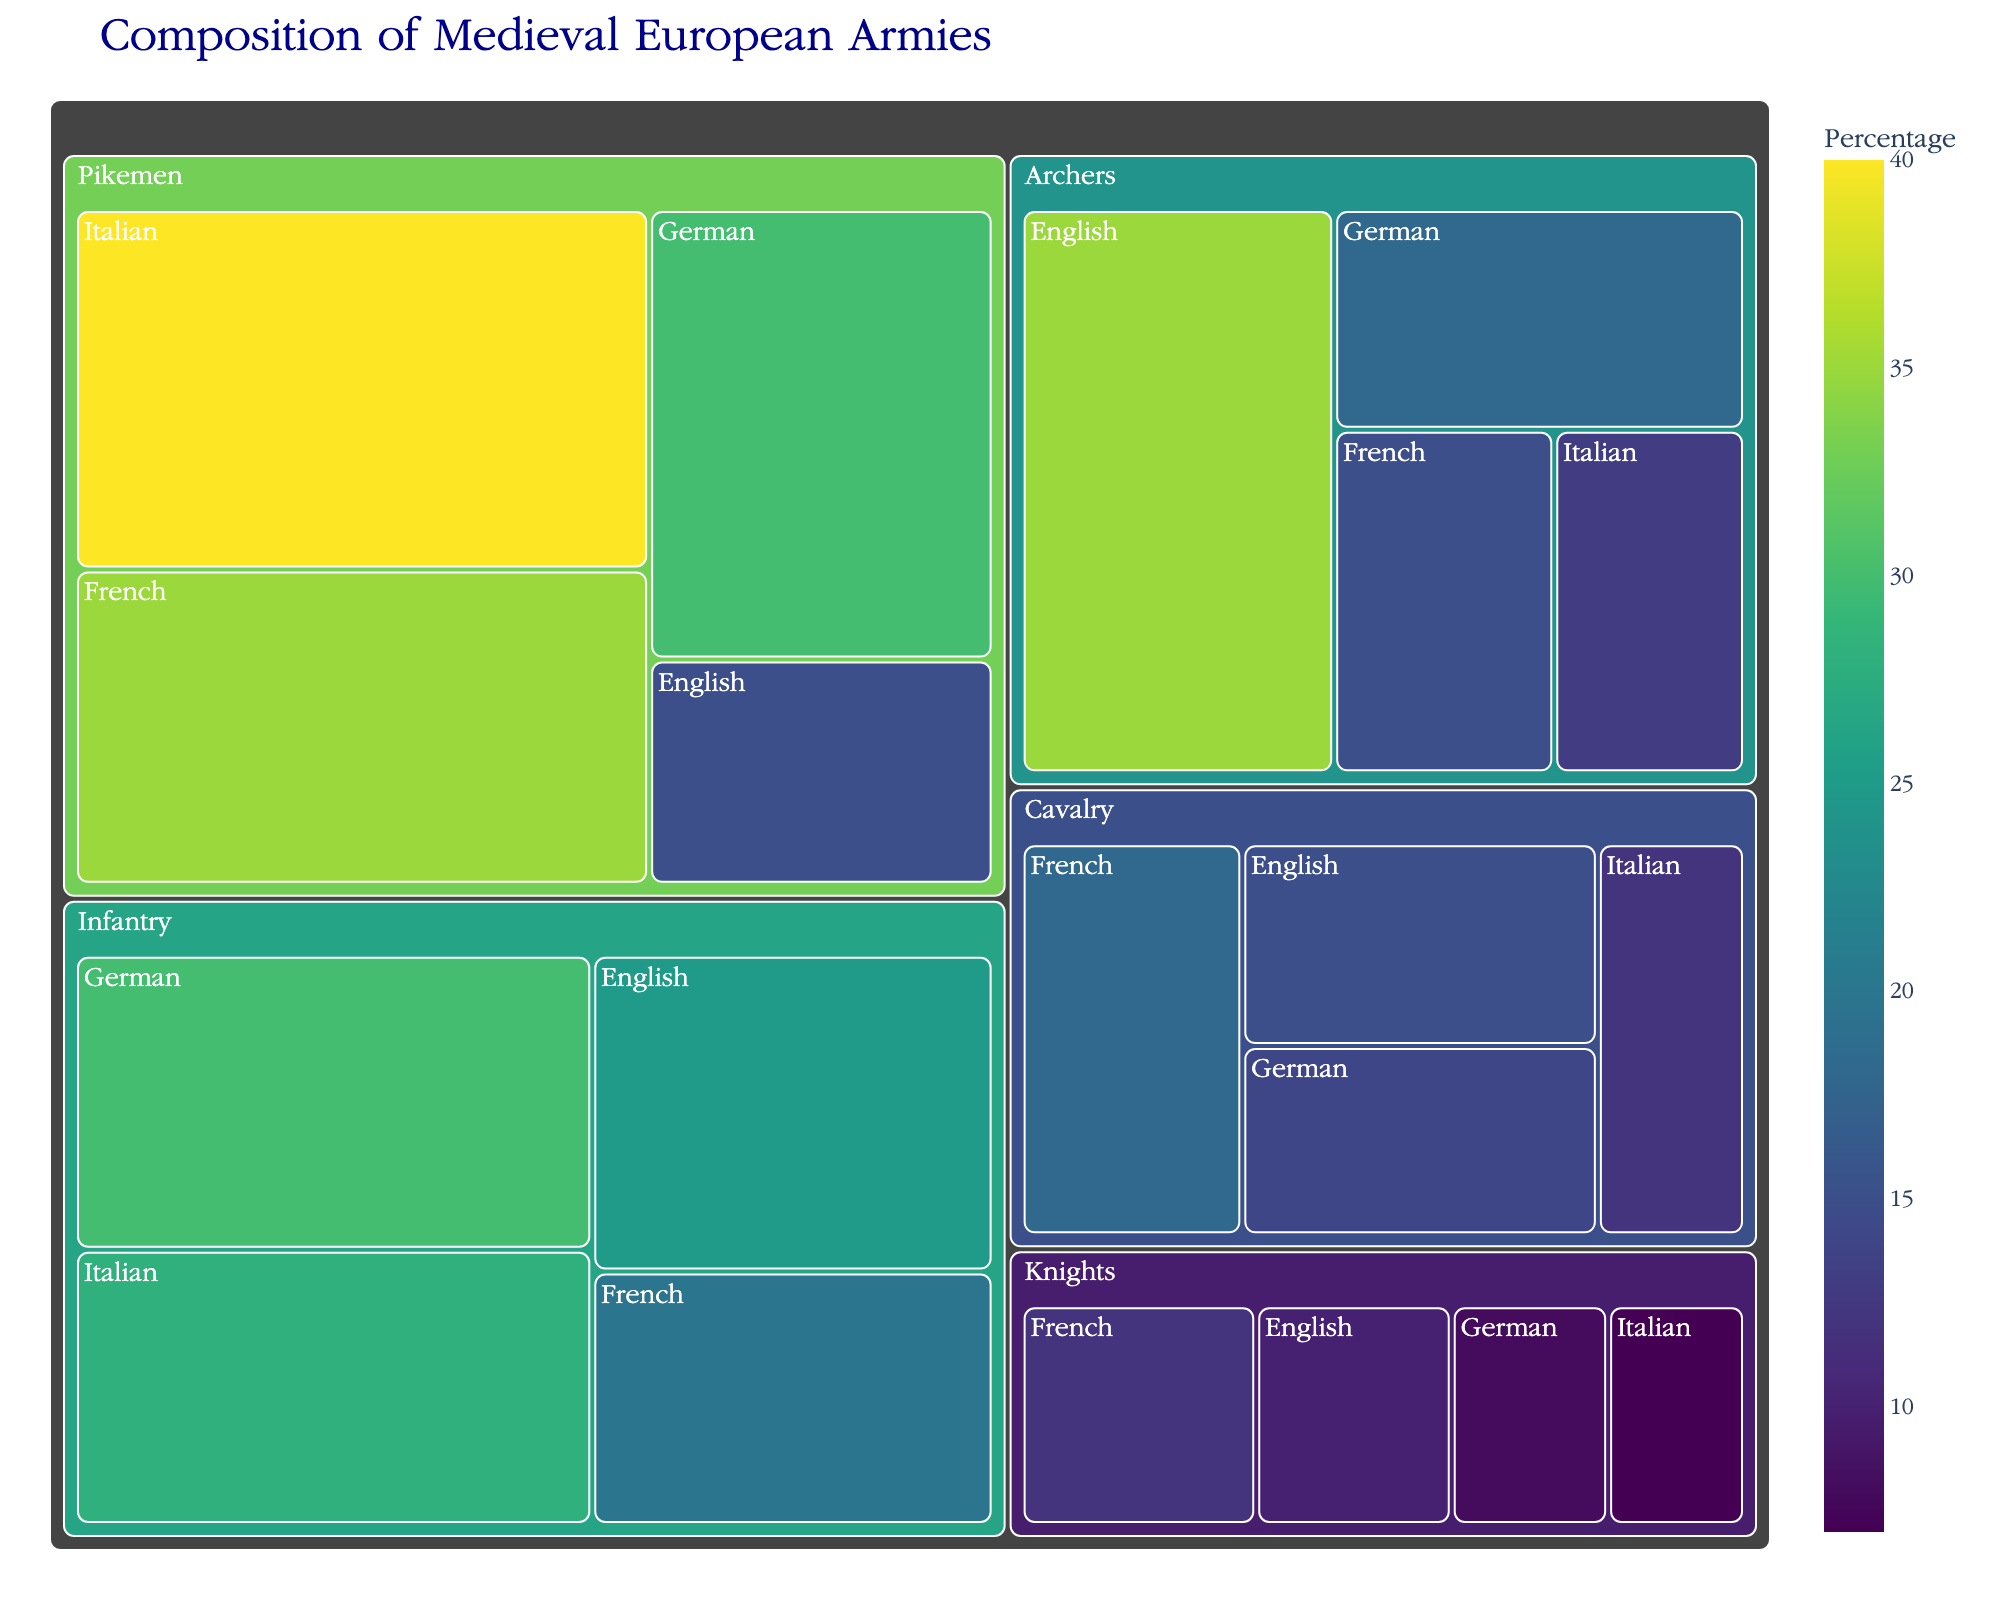what is the highest percentage of any troop type from any nationality? The highest percentage can be found by inspecting each troop type and seeing which has the largest single value. For example, looking at the percentages listed under Pikemen, the Italian Pikemen have the highest percentage at 40%.
Answer: 40% what is the total percentage of knights across all nationalities? To find the total percentage, we need to sum the percentages of knights from each nationality: English (10), French (12), German (8), and Italian (7). So, the total is 10 + 12 + 8 + 7 = 37%.
Answer: 37% Which nationality contributes the largest percentage to the infantry? By examining the percentages for the infantry under each nationality, we see the German Infantry has the highest percentage at 30%.
Answer: German How does the percentage of English cavalry compare to French cavalry? The percentage of English cavalry is 15%, while the French cavalry is 18%. Therefore, the French cavalry has a higher percentage.
Answer: French What is the average percentage of archers across all nationalities? The percentages for archers are: English (35), French (15), German (18), and Italian (13). The average is (35+15+18+13)/4 = 20.25%.
Answer: 20.25% Which troop type has the smallest contribution from the Italian nationality? For each troop type under the Italian nationality, the percentages are Knights (7), Cavalry (12), Infantry (28), Archers (13), and Pikemen (40). The smallest contribution is from the Knights at 7%.
Answer: Knights How do the percentages of English pikemen compare to French pikemen? The percentage for English pikemen is 15%, while the French pikemen percentage is 35%. Thus, the French pikemen have a much higher percentage.
Answer: French What is the combined percentage of German troops (across all troop types)? To find this, sum all the percentages for German troops in each category: Knights (8), Cavalry (14), Infantry (30), Archers (18), and Pikemen (30). The total is 8 + 14 + 30 + 18 + 30 = 100%.
Answer: 100% Which nationality has the highest overall contribution in any single troop type? Looking at the highest individual contributions in each troop type, the Italian Pikemen at 40% is the highest overall contribution.
Answer: Italian What is the difference in percentage between the most and least represented archers nationally? The highest percentage for archers is English (35%) and the lowest is Italian (13%). The difference is 35 - 13 = 22%.
Answer: 22% 